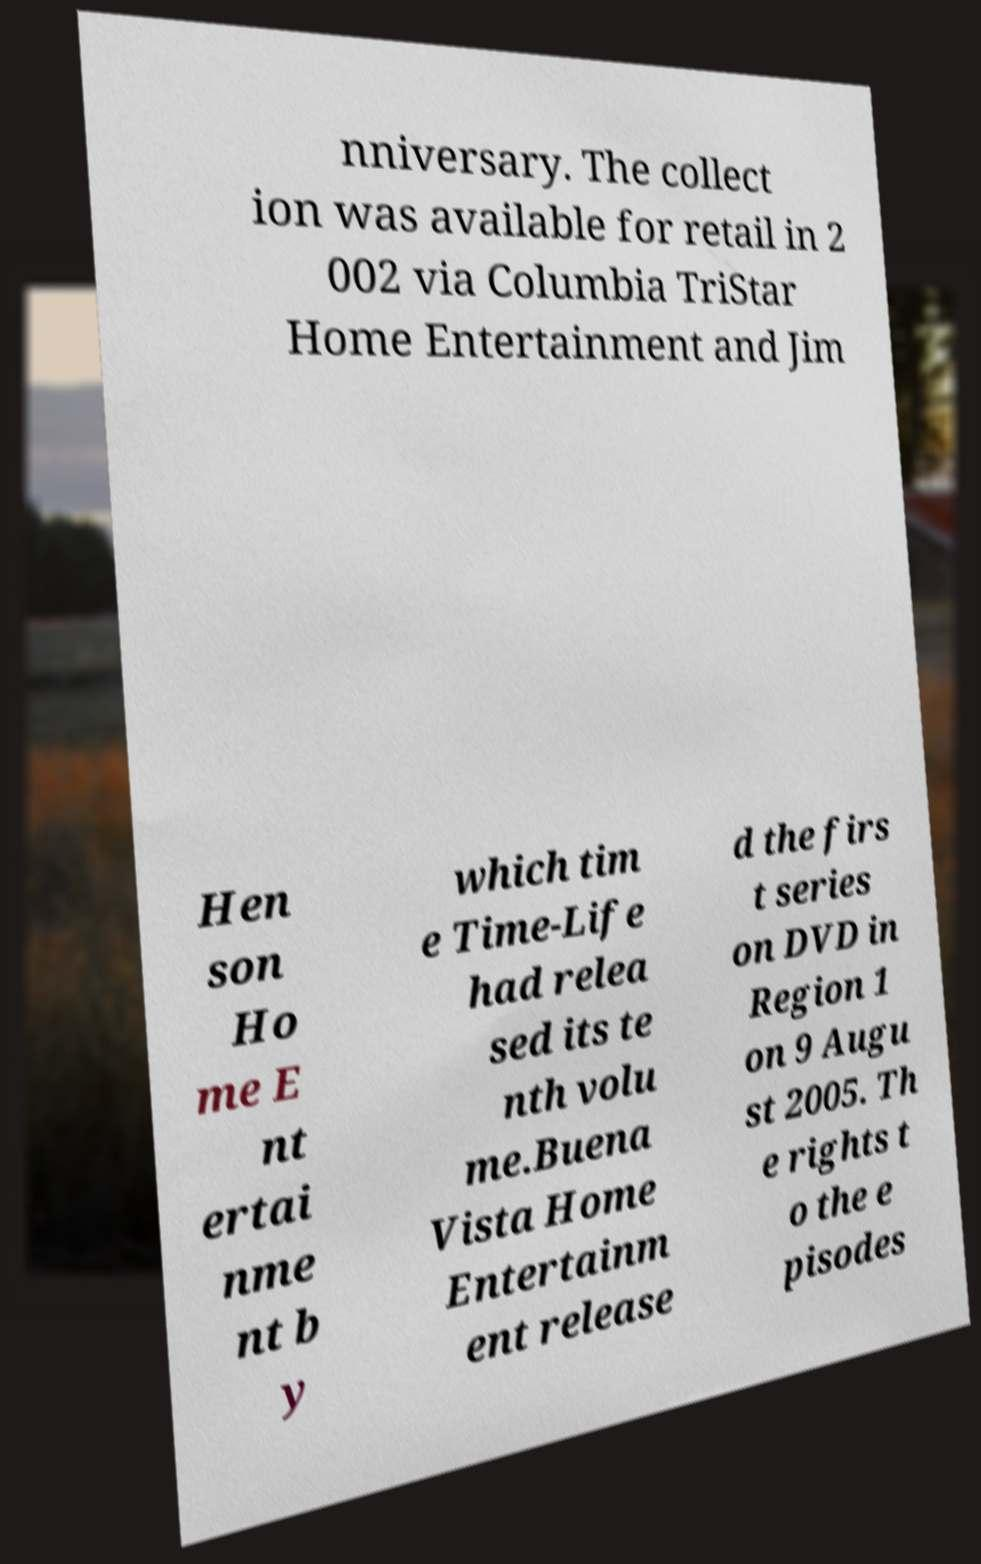Can you read and provide the text displayed in the image?This photo seems to have some interesting text. Can you extract and type it out for me? nniversary. The collect ion was available for retail in 2 002 via Columbia TriStar Home Entertainment and Jim Hen son Ho me E nt ertai nme nt b y which tim e Time-Life had relea sed its te nth volu me.Buena Vista Home Entertainm ent release d the firs t series on DVD in Region 1 on 9 Augu st 2005. Th e rights t o the e pisodes 